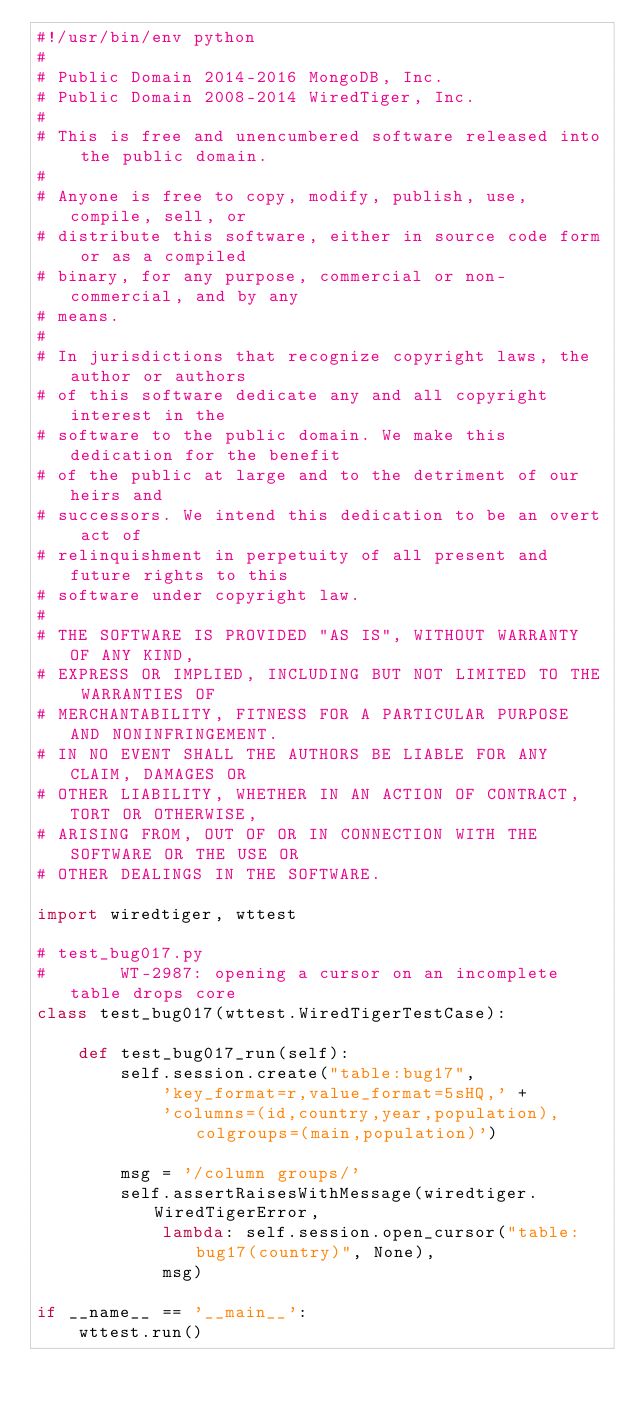<code> <loc_0><loc_0><loc_500><loc_500><_Python_>#!/usr/bin/env python
#
# Public Domain 2014-2016 MongoDB, Inc.
# Public Domain 2008-2014 WiredTiger, Inc.
#
# This is free and unencumbered software released into the public domain.
#
# Anyone is free to copy, modify, publish, use, compile, sell, or
# distribute this software, either in source code form or as a compiled
# binary, for any purpose, commercial or non-commercial, and by any
# means.
#
# In jurisdictions that recognize copyright laws, the author or authors
# of this software dedicate any and all copyright interest in the
# software to the public domain. We make this dedication for the benefit
# of the public at large and to the detriment of our heirs and
# successors. We intend this dedication to be an overt act of
# relinquishment in perpetuity of all present and future rights to this
# software under copyright law.
#
# THE SOFTWARE IS PROVIDED "AS IS", WITHOUT WARRANTY OF ANY KIND,
# EXPRESS OR IMPLIED, INCLUDING BUT NOT LIMITED TO THE WARRANTIES OF
# MERCHANTABILITY, FITNESS FOR A PARTICULAR PURPOSE AND NONINFRINGEMENT.
# IN NO EVENT SHALL THE AUTHORS BE LIABLE FOR ANY CLAIM, DAMAGES OR
# OTHER LIABILITY, WHETHER IN AN ACTION OF CONTRACT, TORT OR OTHERWISE,
# ARISING FROM, OUT OF OR IN CONNECTION WITH THE SOFTWARE OR THE USE OR
# OTHER DEALINGS IN THE SOFTWARE.

import wiredtiger, wttest

# test_bug017.py
#       WT-2987: opening a cursor on an incomplete table drops core
class test_bug017(wttest.WiredTigerTestCase):

    def test_bug017_run(self):
        self.session.create("table:bug17",
            'key_format=r,value_format=5sHQ,' +
            'columns=(id,country,year,population),colgroups=(main,population)')

        msg = '/column groups/'
        self.assertRaisesWithMessage(wiredtiger.WiredTigerError,
            lambda: self.session.open_cursor("table:bug17(country)", None),
            msg)

if __name__ == '__main__':
    wttest.run()
</code> 